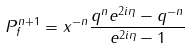<formula> <loc_0><loc_0><loc_500><loc_500>P ^ { n + 1 } _ { f } = x ^ { - n } \frac { q ^ { n } e ^ { 2 i \eta } - q ^ { - n } } { e ^ { 2 i \eta } - 1 }</formula> 